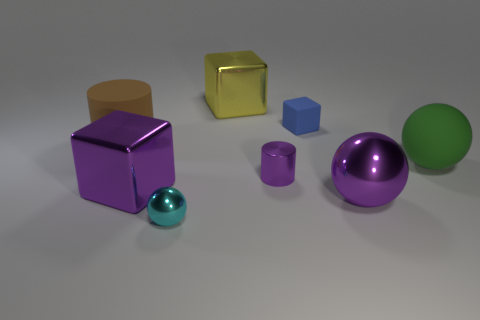There is a big block that is right of the ball that is left of the purple metallic thing that is to the right of the tiny blue thing; what is it made of?
Give a very brief answer. Metal. How many things have the same material as the tiny blue block?
Offer a very short reply. 2. There is a big metallic thing that is the same color as the large shiny ball; what shape is it?
Provide a succinct answer. Cube. The cyan metal thing that is the same size as the rubber cube is what shape?
Your answer should be very brief. Sphere. There is a large block that is the same color as the tiny metal cylinder; what is its material?
Provide a succinct answer. Metal. Are there any yellow objects behind the big purple metallic sphere?
Give a very brief answer. Yes. Are there any purple things of the same shape as the big green matte object?
Provide a succinct answer. Yes. Do the big purple thing on the left side of the cyan object and the tiny thing behind the small purple metal object have the same shape?
Provide a succinct answer. Yes. Is there a green ball that has the same size as the yellow metal cube?
Offer a terse response. Yes. Are there the same number of tiny cyan things behind the large purple cube and yellow things that are in front of the big green rubber thing?
Keep it short and to the point. Yes. 